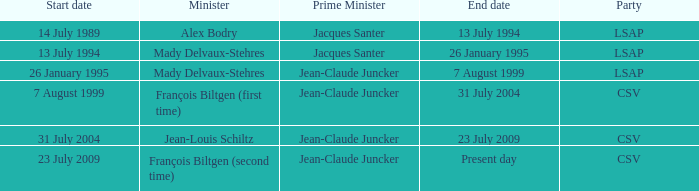Who was the minister for the CSV party with a present day end date? François Biltgen (second time). 